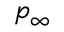Convert formula to latex. <formula><loc_0><loc_0><loc_500><loc_500>p _ { \infty }</formula> 